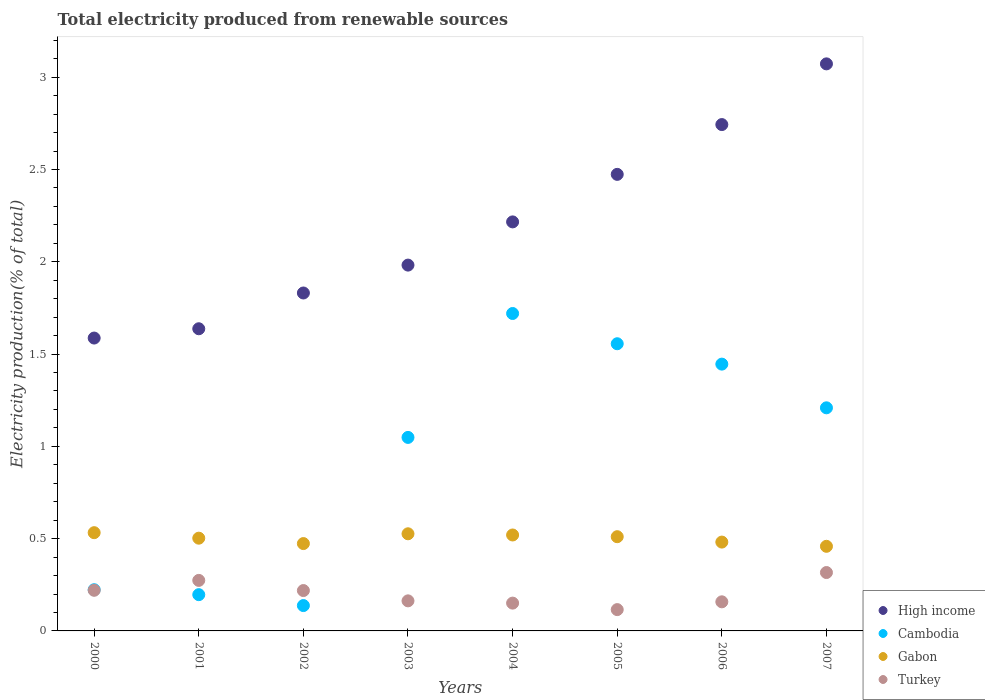What is the total electricity produced in Cambodia in 2005?
Provide a succinct answer. 1.56. Across all years, what is the maximum total electricity produced in Gabon?
Make the answer very short. 0.53. Across all years, what is the minimum total electricity produced in Turkey?
Make the answer very short. 0.12. In which year was the total electricity produced in Turkey maximum?
Provide a succinct answer. 2007. What is the total total electricity produced in Gabon in the graph?
Offer a terse response. 4. What is the difference between the total electricity produced in Turkey in 2005 and that in 2006?
Your answer should be compact. -0.04. What is the difference between the total electricity produced in Turkey in 2000 and the total electricity produced in Gabon in 2007?
Offer a terse response. -0.24. What is the average total electricity produced in Turkey per year?
Ensure brevity in your answer.  0.2. In the year 2002, what is the difference between the total electricity produced in Turkey and total electricity produced in High income?
Provide a succinct answer. -1.61. In how many years, is the total electricity produced in Turkey greater than 1.2 %?
Your answer should be very brief. 0. What is the ratio of the total electricity produced in Gabon in 2006 to that in 2007?
Your answer should be very brief. 1.05. Is the total electricity produced in Gabon in 2000 less than that in 2006?
Your response must be concise. No. Is the difference between the total electricity produced in Turkey in 2002 and 2003 greater than the difference between the total electricity produced in High income in 2002 and 2003?
Keep it short and to the point. Yes. What is the difference between the highest and the second highest total electricity produced in Gabon?
Give a very brief answer. 0.01. What is the difference between the highest and the lowest total electricity produced in Turkey?
Your answer should be compact. 0.2. Is the sum of the total electricity produced in Gabon in 2006 and 2007 greater than the maximum total electricity produced in High income across all years?
Ensure brevity in your answer.  No. Is it the case that in every year, the sum of the total electricity produced in Gabon and total electricity produced in Cambodia  is greater than the total electricity produced in High income?
Provide a succinct answer. No. Is the total electricity produced in High income strictly greater than the total electricity produced in Cambodia over the years?
Provide a succinct answer. Yes. Is the total electricity produced in Cambodia strictly less than the total electricity produced in High income over the years?
Provide a short and direct response. Yes. How many dotlines are there?
Offer a terse response. 4. How many years are there in the graph?
Your answer should be very brief. 8. What is the difference between two consecutive major ticks on the Y-axis?
Ensure brevity in your answer.  0.5. Does the graph contain any zero values?
Your answer should be very brief. No. Does the graph contain grids?
Your response must be concise. No. Where does the legend appear in the graph?
Your response must be concise. Bottom right. How many legend labels are there?
Your response must be concise. 4. How are the legend labels stacked?
Offer a terse response. Vertical. What is the title of the graph?
Ensure brevity in your answer.  Total electricity produced from renewable sources. What is the label or title of the Y-axis?
Offer a very short reply. Electricity production(% of total). What is the Electricity production(% of total) of High income in 2000?
Offer a very short reply. 1.59. What is the Electricity production(% of total) of Cambodia in 2000?
Keep it short and to the point. 0.22. What is the Electricity production(% of total) in Gabon in 2000?
Offer a very short reply. 0.53. What is the Electricity production(% of total) in Turkey in 2000?
Ensure brevity in your answer.  0.22. What is the Electricity production(% of total) of High income in 2001?
Your answer should be very brief. 1.64. What is the Electricity production(% of total) in Cambodia in 2001?
Your answer should be compact. 0.2. What is the Electricity production(% of total) of Gabon in 2001?
Give a very brief answer. 0.5. What is the Electricity production(% of total) of Turkey in 2001?
Your answer should be compact. 0.27. What is the Electricity production(% of total) in High income in 2002?
Ensure brevity in your answer.  1.83. What is the Electricity production(% of total) in Cambodia in 2002?
Offer a terse response. 0.14. What is the Electricity production(% of total) in Gabon in 2002?
Your response must be concise. 0.47. What is the Electricity production(% of total) of Turkey in 2002?
Give a very brief answer. 0.22. What is the Electricity production(% of total) of High income in 2003?
Keep it short and to the point. 1.98. What is the Electricity production(% of total) in Cambodia in 2003?
Give a very brief answer. 1.05. What is the Electricity production(% of total) in Gabon in 2003?
Your answer should be compact. 0.53. What is the Electricity production(% of total) of Turkey in 2003?
Offer a terse response. 0.16. What is the Electricity production(% of total) in High income in 2004?
Offer a very short reply. 2.22. What is the Electricity production(% of total) of Cambodia in 2004?
Offer a terse response. 1.72. What is the Electricity production(% of total) of Gabon in 2004?
Provide a short and direct response. 0.52. What is the Electricity production(% of total) of Turkey in 2004?
Make the answer very short. 0.15. What is the Electricity production(% of total) in High income in 2005?
Your answer should be very brief. 2.47. What is the Electricity production(% of total) of Cambodia in 2005?
Your answer should be very brief. 1.56. What is the Electricity production(% of total) of Gabon in 2005?
Your response must be concise. 0.51. What is the Electricity production(% of total) of Turkey in 2005?
Give a very brief answer. 0.12. What is the Electricity production(% of total) of High income in 2006?
Your response must be concise. 2.74. What is the Electricity production(% of total) of Cambodia in 2006?
Keep it short and to the point. 1.45. What is the Electricity production(% of total) in Gabon in 2006?
Make the answer very short. 0.48. What is the Electricity production(% of total) in Turkey in 2006?
Offer a very short reply. 0.16. What is the Electricity production(% of total) of High income in 2007?
Offer a terse response. 3.07. What is the Electricity production(% of total) in Cambodia in 2007?
Your response must be concise. 1.21. What is the Electricity production(% of total) of Gabon in 2007?
Ensure brevity in your answer.  0.46. What is the Electricity production(% of total) of Turkey in 2007?
Give a very brief answer. 0.32. Across all years, what is the maximum Electricity production(% of total) in High income?
Your answer should be very brief. 3.07. Across all years, what is the maximum Electricity production(% of total) of Cambodia?
Give a very brief answer. 1.72. Across all years, what is the maximum Electricity production(% of total) in Gabon?
Provide a short and direct response. 0.53. Across all years, what is the maximum Electricity production(% of total) in Turkey?
Provide a short and direct response. 0.32. Across all years, what is the minimum Electricity production(% of total) in High income?
Offer a terse response. 1.59. Across all years, what is the minimum Electricity production(% of total) in Cambodia?
Provide a short and direct response. 0.14. Across all years, what is the minimum Electricity production(% of total) in Gabon?
Offer a terse response. 0.46. Across all years, what is the minimum Electricity production(% of total) in Turkey?
Your answer should be compact. 0.12. What is the total Electricity production(% of total) in High income in the graph?
Give a very brief answer. 17.54. What is the total Electricity production(% of total) in Cambodia in the graph?
Keep it short and to the point. 7.54. What is the total Electricity production(% of total) in Gabon in the graph?
Provide a short and direct response. 4. What is the total Electricity production(% of total) in Turkey in the graph?
Offer a terse response. 1.62. What is the difference between the Electricity production(% of total) of High income in 2000 and that in 2001?
Keep it short and to the point. -0.05. What is the difference between the Electricity production(% of total) in Cambodia in 2000 and that in 2001?
Your answer should be compact. 0.03. What is the difference between the Electricity production(% of total) in Gabon in 2000 and that in 2001?
Your response must be concise. 0.03. What is the difference between the Electricity production(% of total) of Turkey in 2000 and that in 2001?
Keep it short and to the point. -0.05. What is the difference between the Electricity production(% of total) in High income in 2000 and that in 2002?
Provide a short and direct response. -0.24. What is the difference between the Electricity production(% of total) of Cambodia in 2000 and that in 2002?
Keep it short and to the point. 0.09. What is the difference between the Electricity production(% of total) of Gabon in 2000 and that in 2002?
Provide a succinct answer. 0.06. What is the difference between the Electricity production(% of total) of Turkey in 2000 and that in 2002?
Your answer should be very brief. 0. What is the difference between the Electricity production(% of total) in High income in 2000 and that in 2003?
Give a very brief answer. -0.4. What is the difference between the Electricity production(% of total) in Cambodia in 2000 and that in 2003?
Offer a terse response. -0.83. What is the difference between the Electricity production(% of total) of Gabon in 2000 and that in 2003?
Your answer should be very brief. 0.01. What is the difference between the Electricity production(% of total) in Turkey in 2000 and that in 2003?
Ensure brevity in your answer.  0.06. What is the difference between the Electricity production(% of total) in High income in 2000 and that in 2004?
Ensure brevity in your answer.  -0.63. What is the difference between the Electricity production(% of total) of Cambodia in 2000 and that in 2004?
Keep it short and to the point. -1.5. What is the difference between the Electricity production(% of total) in Gabon in 2000 and that in 2004?
Make the answer very short. 0.01. What is the difference between the Electricity production(% of total) of Turkey in 2000 and that in 2004?
Offer a terse response. 0.07. What is the difference between the Electricity production(% of total) of High income in 2000 and that in 2005?
Offer a terse response. -0.89. What is the difference between the Electricity production(% of total) of Cambodia in 2000 and that in 2005?
Your answer should be compact. -1.33. What is the difference between the Electricity production(% of total) in Gabon in 2000 and that in 2005?
Keep it short and to the point. 0.02. What is the difference between the Electricity production(% of total) of Turkey in 2000 and that in 2005?
Your answer should be compact. 0.1. What is the difference between the Electricity production(% of total) of High income in 2000 and that in 2006?
Make the answer very short. -1.16. What is the difference between the Electricity production(% of total) of Cambodia in 2000 and that in 2006?
Provide a short and direct response. -1.22. What is the difference between the Electricity production(% of total) in Gabon in 2000 and that in 2006?
Your answer should be compact. 0.05. What is the difference between the Electricity production(% of total) in Turkey in 2000 and that in 2006?
Ensure brevity in your answer.  0.06. What is the difference between the Electricity production(% of total) of High income in 2000 and that in 2007?
Your response must be concise. -1.49. What is the difference between the Electricity production(% of total) of Cambodia in 2000 and that in 2007?
Your answer should be very brief. -0.99. What is the difference between the Electricity production(% of total) in Gabon in 2000 and that in 2007?
Your answer should be compact. 0.07. What is the difference between the Electricity production(% of total) in Turkey in 2000 and that in 2007?
Offer a very short reply. -0.1. What is the difference between the Electricity production(% of total) of High income in 2001 and that in 2002?
Your answer should be very brief. -0.19. What is the difference between the Electricity production(% of total) of Cambodia in 2001 and that in 2002?
Offer a very short reply. 0.06. What is the difference between the Electricity production(% of total) in Gabon in 2001 and that in 2002?
Your answer should be compact. 0.03. What is the difference between the Electricity production(% of total) in Turkey in 2001 and that in 2002?
Your answer should be compact. 0.06. What is the difference between the Electricity production(% of total) of High income in 2001 and that in 2003?
Your response must be concise. -0.34. What is the difference between the Electricity production(% of total) in Cambodia in 2001 and that in 2003?
Give a very brief answer. -0.85. What is the difference between the Electricity production(% of total) in Gabon in 2001 and that in 2003?
Offer a terse response. -0.02. What is the difference between the Electricity production(% of total) in Turkey in 2001 and that in 2003?
Your answer should be compact. 0.11. What is the difference between the Electricity production(% of total) in High income in 2001 and that in 2004?
Provide a short and direct response. -0.58. What is the difference between the Electricity production(% of total) in Cambodia in 2001 and that in 2004?
Offer a terse response. -1.52. What is the difference between the Electricity production(% of total) in Gabon in 2001 and that in 2004?
Make the answer very short. -0.02. What is the difference between the Electricity production(% of total) of Turkey in 2001 and that in 2004?
Provide a short and direct response. 0.12. What is the difference between the Electricity production(% of total) of High income in 2001 and that in 2005?
Ensure brevity in your answer.  -0.84. What is the difference between the Electricity production(% of total) in Cambodia in 2001 and that in 2005?
Offer a very short reply. -1.36. What is the difference between the Electricity production(% of total) of Gabon in 2001 and that in 2005?
Ensure brevity in your answer.  -0.01. What is the difference between the Electricity production(% of total) in Turkey in 2001 and that in 2005?
Ensure brevity in your answer.  0.16. What is the difference between the Electricity production(% of total) in High income in 2001 and that in 2006?
Offer a terse response. -1.11. What is the difference between the Electricity production(% of total) of Cambodia in 2001 and that in 2006?
Offer a very short reply. -1.25. What is the difference between the Electricity production(% of total) in Gabon in 2001 and that in 2006?
Offer a terse response. 0.02. What is the difference between the Electricity production(% of total) in Turkey in 2001 and that in 2006?
Make the answer very short. 0.12. What is the difference between the Electricity production(% of total) of High income in 2001 and that in 2007?
Make the answer very short. -1.44. What is the difference between the Electricity production(% of total) of Cambodia in 2001 and that in 2007?
Keep it short and to the point. -1.01. What is the difference between the Electricity production(% of total) in Gabon in 2001 and that in 2007?
Your response must be concise. 0.04. What is the difference between the Electricity production(% of total) in Turkey in 2001 and that in 2007?
Keep it short and to the point. -0.04. What is the difference between the Electricity production(% of total) in High income in 2002 and that in 2003?
Your response must be concise. -0.15. What is the difference between the Electricity production(% of total) of Cambodia in 2002 and that in 2003?
Your answer should be compact. -0.91. What is the difference between the Electricity production(% of total) of Gabon in 2002 and that in 2003?
Your response must be concise. -0.05. What is the difference between the Electricity production(% of total) in Turkey in 2002 and that in 2003?
Give a very brief answer. 0.06. What is the difference between the Electricity production(% of total) in High income in 2002 and that in 2004?
Your answer should be very brief. -0.39. What is the difference between the Electricity production(% of total) in Cambodia in 2002 and that in 2004?
Offer a terse response. -1.58. What is the difference between the Electricity production(% of total) in Gabon in 2002 and that in 2004?
Give a very brief answer. -0.05. What is the difference between the Electricity production(% of total) in Turkey in 2002 and that in 2004?
Offer a very short reply. 0.07. What is the difference between the Electricity production(% of total) of High income in 2002 and that in 2005?
Give a very brief answer. -0.64. What is the difference between the Electricity production(% of total) in Cambodia in 2002 and that in 2005?
Provide a short and direct response. -1.42. What is the difference between the Electricity production(% of total) of Gabon in 2002 and that in 2005?
Make the answer very short. -0.04. What is the difference between the Electricity production(% of total) of Turkey in 2002 and that in 2005?
Offer a very short reply. 0.1. What is the difference between the Electricity production(% of total) in High income in 2002 and that in 2006?
Your answer should be very brief. -0.91. What is the difference between the Electricity production(% of total) in Cambodia in 2002 and that in 2006?
Provide a short and direct response. -1.31. What is the difference between the Electricity production(% of total) of Gabon in 2002 and that in 2006?
Keep it short and to the point. -0.01. What is the difference between the Electricity production(% of total) in Turkey in 2002 and that in 2006?
Your answer should be very brief. 0.06. What is the difference between the Electricity production(% of total) of High income in 2002 and that in 2007?
Give a very brief answer. -1.24. What is the difference between the Electricity production(% of total) of Cambodia in 2002 and that in 2007?
Offer a terse response. -1.07. What is the difference between the Electricity production(% of total) in Gabon in 2002 and that in 2007?
Provide a short and direct response. 0.01. What is the difference between the Electricity production(% of total) in Turkey in 2002 and that in 2007?
Your answer should be compact. -0.1. What is the difference between the Electricity production(% of total) in High income in 2003 and that in 2004?
Offer a very short reply. -0.23. What is the difference between the Electricity production(% of total) in Cambodia in 2003 and that in 2004?
Ensure brevity in your answer.  -0.67. What is the difference between the Electricity production(% of total) of Gabon in 2003 and that in 2004?
Offer a very short reply. 0.01. What is the difference between the Electricity production(% of total) in Turkey in 2003 and that in 2004?
Provide a succinct answer. 0.01. What is the difference between the Electricity production(% of total) in High income in 2003 and that in 2005?
Ensure brevity in your answer.  -0.49. What is the difference between the Electricity production(% of total) in Cambodia in 2003 and that in 2005?
Your answer should be compact. -0.51. What is the difference between the Electricity production(% of total) in Gabon in 2003 and that in 2005?
Keep it short and to the point. 0.02. What is the difference between the Electricity production(% of total) in Turkey in 2003 and that in 2005?
Make the answer very short. 0.05. What is the difference between the Electricity production(% of total) of High income in 2003 and that in 2006?
Keep it short and to the point. -0.76. What is the difference between the Electricity production(% of total) of Cambodia in 2003 and that in 2006?
Keep it short and to the point. -0.4. What is the difference between the Electricity production(% of total) in Gabon in 2003 and that in 2006?
Offer a very short reply. 0.04. What is the difference between the Electricity production(% of total) of Turkey in 2003 and that in 2006?
Offer a terse response. 0.01. What is the difference between the Electricity production(% of total) of High income in 2003 and that in 2007?
Ensure brevity in your answer.  -1.09. What is the difference between the Electricity production(% of total) of Cambodia in 2003 and that in 2007?
Your answer should be compact. -0.16. What is the difference between the Electricity production(% of total) in Gabon in 2003 and that in 2007?
Your answer should be very brief. 0.07. What is the difference between the Electricity production(% of total) in Turkey in 2003 and that in 2007?
Ensure brevity in your answer.  -0.15. What is the difference between the Electricity production(% of total) in High income in 2004 and that in 2005?
Your answer should be compact. -0.26. What is the difference between the Electricity production(% of total) of Cambodia in 2004 and that in 2005?
Offer a terse response. 0.16. What is the difference between the Electricity production(% of total) of Gabon in 2004 and that in 2005?
Offer a very short reply. 0.01. What is the difference between the Electricity production(% of total) in Turkey in 2004 and that in 2005?
Keep it short and to the point. 0.04. What is the difference between the Electricity production(% of total) in High income in 2004 and that in 2006?
Give a very brief answer. -0.53. What is the difference between the Electricity production(% of total) of Cambodia in 2004 and that in 2006?
Ensure brevity in your answer.  0.27. What is the difference between the Electricity production(% of total) of Gabon in 2004 and that in 2006?
Offer a terse response. 0.04. What is the difference between the Electricity production(% of total) of Turkey in 2004 and that in 2006?
Your response must be concise. -0.01. What is the difference between the Electricity production(% of total) of High income in 2004 and that in 2007?
Make the answer very short. -0.86. What is the difference between the Electricity production(% of total) in Cambodia in 2004 and that in 2007?
Your response must be concise. 0.51. What is the difference between the Electricity production(% of total) of Gabon in 2004 and that in 2007?
Offer a very short reply. 0.06. What is the difference between the Electricity production(% of total) of Turkey in 2004 and that in 2007?
Provide a short and direct response. -0.17. What is the difference between the Electricity production(% of total) of High income in 2005 and that in 2006?
Offer a very short reply. -0.27. What is the difference between the Electricity production(% of total) of Cambodia in 2005 and that in 2006?
Give a very brief answer. 0.11. What is the difference between the Electricity production(% of total) of Gabon in 2005 and that in 2006?
Your response must be concise. 0.03. What is the difference between the Electricity production(% of total) in Turkey in 2005 and that in 2006?
Offer a terse response. -0.04. What is the difference between the Electricity production(% of total) of High income in 2005 and that in 2007?
Your response must be concise. -0.6. What is the difference between the Electricity production(% of total) of Cambodia in 2005 and that in 2007?
Provide a short and direct response. 0.35. What is the difference between the Electricity production(% of total) in Gabon in 2005 and that in 2007?
Offer a terse response. 0.05. What is the difference between the Electricity production(% of total) in Turkey in 2005 and that in 2007?
Your answer should be compact. -0.2. What is the difference between the Electricity production(% of total) of High income in 2006 and that in 2007?
Provide a succinct answer. -0.33. What is the difference between the Electricity production(% of total) of Cambodia in 2006 and that in 2007?
Keep it short and to the point. 0.24. What is the difference between the Electricity production(% of total) in Gabon in 2006 and that in 2007?
Your answer should be compact. 0.02. What is the difference between the Electricity production(% of total) in Turkey in 2006 and that in 2007?
Offer a very short reply. -0.16. What is the difference between the Electricity production(% of total) of High income in 2000 and the Electricity production(% of total) of Cambodia in 2001?
Your answer should be compact. 1.39. What is the difference between the Electricity production(% of total) of High income in 2000 and the Electricity production(% of total) of Gabon in 2001?
Your answer should be very brief. 1.08. What is the difference between the Electricity production(% of total) of High income in 2000 and the Electricity production(% of total) of Turkey in 2001?
Give a very brief answer. 1.31. What is the difference between the Electricity production(% of total) in Cambodia in 2000 and the Electricity production(% of total) in Gabon in 2001?
Provide a short and direct response. -0.28. What is the difference between the Electricity production(% of total) of Cambodia in 2000 and the Electricity production(% of total) of Turkey in 2001?
Offer a terse response. -0.05. What is the difference between the Electricity production(% of total) of Gabon in 2000 and the Electricity production(% of total) of Turkey in 2001?
Provide a short and direct response. 0.26. What is the difference between the Electricity production(% of total) in High income in 2000 and the Electricity production(% of total) in Cambodia in 2002?
Your answer should be very brief. 1.45. What is the difference between the Electricity production(% of total) of High income in 2000 and the Electricity production(% of total) of Gabon in 2002?
Give a very brief answer. 1.11. What is the difference between the Electricity production(% of total) in High income in 2000 and the Electricity production(% of total) in Turkey in 2002?
Ensure brevity in your answer.  1.37. What is the difference between the Electricity production(% of total) in Cambodia in 2000 and the Electricity production(% of total) in Gabon in 2002?
Ensure brevity in your answer.  -0.25. What is the difference between the Electricity production(% of total) in Cambodia in 2000 and the Electricity production(% of total) in Turkey in 2002?
Provide a short and direct response. 0. What is the difference between the Electricity production(% of total) in Gabon in 2000 and the Electricity production(% of total) in Turkey in 2002?
Offer a very short reply. 0.31. What is the difference between the Electricity production(% of total) in High income in 2000 and the Electricity production(% of total) in Cambodia in 2003?
Make the answer very short. 0.54. What is the difference between the Electricity production(% of total) in High income in 2000 and the Electricity production(% of total) in Gabon in 2003?
Keep it short and to the point. 1.06. What is the difference between the Electricity production(% of total) in High income in 2000 and the Electricity production(% of total) in Turkey in 2003?
Ensure brevity in your answer.  1.42. What is the difference between the Electricity production(% of total) of Cambodia in 2000 and the Electricity production(% of total) of Gabon in 2003?
Your answer should be compact. -0.3. What is the difference between the Electricity production(% of total) of Cambodia in 2000 and the Electricity production(% of total) of Turkey in 2003?
Provide a succinct answer. 0.06. What is the difference between the Electricity production(% of total) of Gabon in 2000 and the Electricity production(% of total) of Turkey in 2003?
Keep it short and to the point. 0.37. What is the difference between the Electricity production(% of total) of High income in 2000 and the Electricity production(% of total) of Cambodia in 2004?
Keep it short and to the point. -0.13. What is the difference between the Electricity production(% of total) in High income in 2000 and the Electricity production(% of total) in Gabon in 2004?
Provide a succinct answer. 1.07. What is the difference between the Electricity production(% of total) of High income in 2000 and the Electricity production(% of total) of Turkey in 2004?
Provide a succinct answer. 1.44. What is the difference between the Electricity production(% of total) in Cambodia in 2000 and the Electricity production(% of total) in Gabon in 2004?
Ensure brevity in your answer.  -0.3. What is the difference between the Electricity production(% of total) in Cambodia in 2000 and the Electricity production(% of total) in Turkey in 2004?
Provide a short and direct response. 0.07. What is the difference between the Electricity production(% of total) in Gabon in 2000 and the Electricity production(% of total) in Turkey in 2004?
Your answer should be very brief. 0.38. What is the difference between the Electricity production(% of total) in High income in 2000 and the Electricity production(% of total) in Cambodia in 2005?
Your response must be concise. 0.03. What is the difference between the Electricity production(% of total) of High income in 2000 and the Electricity production(% of total) of Gabon in 2005?
Your answer should be very brief. 1.08. What is the difference between the Electricity production(% of total) of High income in 2000 and the Electricity production(% of total) of Turkey in 2005?
Make the answer very short. 1.47. What is the difference between the Electricity production(% of total) of Cambodia in 2000 and the Electricity production(% of total) of Gabon in 2005?
Your answer should be compact. -0.29. What is the difference between the Electricity production(% of total) of Cambodia in 2000 and the Electricity production(% of total) of Turkey in 2005?
Your response must be concise. 0.11. What is the difference between the Electricity production(% of total) of Gabon in 2000 and the Electricity production(% of total) of Turkey in 2005?
Your answer should be compact. 0.42. What is the difference between the Electricity production(% of total) in High income in 2000 and the Electricity production(% of total) in Cambodia in 2006?
Offer a terse response. 0.14. What is the difference between the Electricity production(% of total) of High income in 2000 and the Electricity production(% of total) of Gabon in 2006?
Your response must be concise. 1.11. What is the difference between the Electricity production(% of total) of High income in 2000 and the Electricity production(% of total) of Turkey in 2006?
Give a very brief answer. 1.43. What is the difference between the Electricity production(% of total) of Cambodia in 2000 and the Electricity production(% of total) of Gabon in 2006?
Your answer should be very brief. -0.26. What is the difference between the Electricity production(% of total) in Cambodia in 2000 and the Electricity production(% of total) in Turkey in 2006?
Make the answer very short. 0.07. What is the difference between the Electricity production(% of total) in Gabon in 2000 and the Electricity production(% of total) in Turkey in 2006?
Your answer should be very brief. 0.37. What is the difference between the Electricity production(% of total) in High income in 2000 and the Electricity production(% of total) in Cambodia in 2007?
Your answer should be very brief. 0.38. What is the difference between the Electricity production(% of total) of High income in 2000 and the Electricity production(% of total) of Gabon in 2007?
Your response must be concise. 1.13. What is the difference between the Electricity production(% of total) of High income in 2000 and the Electricity production(% of total) of Turkey in 2007?
Your response must be concise. 1.27. What is the difference between the Electricity production(% of total) of Cambodia in 2000 and the Electricity production(% of total) of Gabon in 2007?
Your answer should be very brief. -0.24. What is the difference between the Electricity production(% of total) in Cambodia in 2000 and the Electricity production(% of total) in Turkey in 2007?
Offer a terse response. -0.09. What is the difference between the Electricity production(% of total) of Gabon in 2000 and the Electricity production(% of total) of Turkey in 2007?
Make the answer very short. 0.22. What is the difference between the Electricity production(% of total) in High income in 2001 and the Electricity production(% of total) in Cambodia in 2002?
Your response must be concise. 1.5. What is the difference between the Electricity production(% of total) in High income in 2001 and the Electricity production(% of total) in Gabon in 2002?
Provide a short and direct response. 1.16. What is the difference between the Electricity production(% of total) of High income in 2001 and the Electricity production(% of total) of Turkey in 2002?
Provide a short and direct response. 1.42. What is the difference between the Electricity production(% of total) of Cambodia in 2001 and the Electricity production(% of total) of Gabon in 2002?
Provide a succinct answer. -0.28. What is the difference between the Electricity production(% of total) of Cambodia in 2001 and the Electricity production(% of total) of Turkey in 2002?
Keep it short and to the point. -0.02. What is the difference between the Electricity production(% of total) of Gabon in 2001 and the Electricity production(% of total) of Turkey in 2002?
Your response must be concise. 0.28. What is the difference between the Electricity production(% of total) of High income in 2001 and the Electricity production(% of total) of Cambodia in 2003?
Provide a succinct answer. 0.59. What is the difference between the Electricity production(% of total) of High income in 2001 and the Electricity production(% of total) of Gabon in 2003?
Make the answer very short. 1.11. What is the difference between the Electricity production(% of total) in High income in 2001 and the Electricity production(% of total) in Turkey in 2003?
Your answer should be very brief. 1.47. What is the difference between the Electricity production(% of total) in Cambodia in 2001 and the Electricity production(% of total) in Gabon in 2003?
Offer a terse response. -0.33. What is the difference between the Electricity production(% of total) of Cambodia in 2001 and the Electricity production(% of total) of Turkey in 2003?
Provide a short and direct response. 0.03. What is the difference between the Electricity production(% of total) of Gabon in 2001 and the Electricity production(% of total) of Turkey in 2003?
Your answer should be very brief. 0.34. What is the difference between the Electricity production(% of total) of High income in 2001 and the Electricity production(% of total) of Cambodia in 2004?
Provide a short and direct response. -0.08. What is the difference between the Electricity production(% of total) of High income in 2001 and the Electricity production(% of total) of Gabon in 2004?
Offer a terse response. 1.12. What is the difference between the Electricity production(% of total) in High income in 2001 and the Electricity production(% of total) in Turkey in 2004?
Your response must be concise. 1.49. What is the difference between the Electricity production(% of total) in Cambodia in 2001 and the Electricity production(% of total) in Gabon in 2004?
Give a very brief answer. -0.32. What is the difference between the Electricity production(% of total) in Cambodia in 2001 and the Electricity production(% of total) in Turkey in 2004?
Your answer should be very brief. 0.05. What is the difference between the Electricity production(% of total) of Gabon in 2001 and the Electricity production(% of total) of Turkey in 2004?
Your response must be concise. 0.35. What is the difference between the Electricity production(% of total) in High income in 2001 and the Electricity production(% of total) in Cambodia in 2005?
Provide a short and direct response. 0.08. What is the difference between the Electricity production(% of total) of High income in 2001 and the Electricity production(% of total) of Gabon in 2005?
Provide a succinct answer. 1.13. What is the difference between the Electricity production(% of total) in High income in 2001 and the Electricity production(% of total) in Turkey in 2005?
Your response must be concise. 1.52. What is the difference between the Electricity production(% of total) in Cambodia in 2001 and the Electricity production(% of total) in Gabon in 2005?
Provide a succinct answer. -0.31. What is the difference between the Electricity production(% of total) of Cambodia in 2001 and the Electricity production(% of total) of Turkey in 2005?
Provide a succinct answer. 0.08. What is the difference between the Electricity production(% of total) of Gabon in 2001 and the Electricity production(% of total) of Turkey in 2005?
Keep it short and to the point. 0.39. What is the difference between the Electricity production(% of total) in High income in 2001 and the Electricity production(% of total) in Cambodia in 2006?
Your response must be concise. 0.19. What is the difference between the Electricity production(% of total) in High income in 2001 and the Electricity production(% of total) in Gabon in 2006?
Ensure brevity in your answer.  1.16. What is the difference between the Electricity production(% of total) of High income in 2001 and the Electricity production(% of total) of Turkey in 2006?
Your response must be concise. 1.48. What is the difference between the Electricity production(% of total) of Cambodia in 2001 and the Electricity production(% of total) of Gabon in 2006?
Your response must be concise. -0.28. What is the difference between the Electricity production(% of total) in Cambodia in 2001 and the Electricity production(% of total) in Turkey in 2006?
Your answer should be very brief. 0.04. What is the difference between the Electricity production(% of total) in Gabon in 2001 and the Electricity production(% of total) in Turkey in 2006?
Offer a terse response. 0.34. What is the difference between the Electricity production(% of total) in High income in 2001 and the Electricity production(% of total) in Cambodia in 2007?
Your answer should be very brief. 0.43. What is the difference between the Electricity production(% of total) in High income in 2001 and the Electricity production(% of total) in Gabon in 2007?
Provide a succinct answer. 1.18. What is the difference between the Electricity production(% of total) of High income in 2001 and the Electricity production(% of total) of Turkey in 2007?
Keep it short and to the point. 1.32. What is the difference between the Electricity production(% of total) of Cambodia in 2001 and the Electricity production(% of total) of Gabon in 2007?
Your answer should be compact. -0.26. What is the difference between the Electricity production(% of total) of Cambodia in 2001 and the Electricity production(% of total) of Turkey in 2007?
Your answer should be compact. -0.12. What is the difference between the Electricity production(% of total) of Gabon in 2001 and the Electricity production(% of total) of Turkey in 2007?
Give a very brief answer. 0.19. What is the difference between the Electricity production(% of total) in High income in 2002 and the Electricity production(% of total) in Cambodia in 2003?
Your response must be concise. 0.78. What is the difference between the Electricity production(% of total) of High income in 2002 and the Electricity production(% of total) of Gabon in 2003?
Make the answer very short. 1.3. What is the difference between the Electricity production(% of total) of High income in 2002 and the Electricity production(% of total) of Turkey in 2003?
Give a very brief answer. 1.67. What is the difference between the Electricity production(% of total) in Cambodia in 2002 and the Electricity production(% of total) in Gabon in 2003?
Keep it short and to the point. -0.39. What is the difference between the Electricity production(% of total) in Cambodia in 2002 and the Electricity production(% of total) in Turkey in 2003?
Your answer should be compact. -0.03. What is the difference between the Electricity production(% of total) of Gabon in 2002 and the Electricity production(% of total) of Turkey in 2003?
Give a very brief answer. 0.31. What is the difference between the Electricity production(% of total) in High income in 2002 and the Electricity production(% of total) in Cambodia in 2004?
Keep it short and to the point. 0.11. What is the difference between the Electricity production(% of total) in High income in 2002 and the Electricity production(% of total) in Gabon in 2004?
Give a very brief answer. 1.31. What is the difference between the Electricity production(% of total) in High income in 2002 and the Electricity production(% of total) in Turkey in 2004?
Offer a very short reply. 1.68. What is the difference between the Electricity production(% of total) in Cambodia in 2002 and the Electricity production(% of total) in Gabon in 2004?
Your answer should be compact. -0.38. What is the difference between the Electricity production(% of total) of Cambodia in 2002 and the Electricity production(% of total) of Turkey in 2004?
Ensure brevity in your answer.  -0.01. What is the difference between the Electricity production(% of total) in Gabon in 2002 and the Electricity production(% of total) in Turkey in 2004?
Offer a very short reply. 0.32. What is the difference between the Electricity production(% of total) in High income in 2002 and the Electricity production(% of total) in Cambodia in 2005?
Your answer should be compact. 0.28. What is the difference between the Electricity production(% of total) of High income in 2002 and the Electricity production(% of total) of Gabon in 2005?
Offer a terse response. 1.32. What is the difference between the Electricity production(% of total) of High income in 2002 and the Electricity production(% of total) of Turkey in 2005?
Ensure brevity in your answer.  1.72. What is the difference between the Electricity production(% of total) in Cambodia in 2002 and the Electricity production(% of total) in Gabon in 2005?
Give a very brief answer. -0.37. What is the difference between the Electricity production(% of total) of Cambodia in 2002 and the Electricity production(% of total) of Turkey in 2005?
Provide a short and direct response. 0.02. What is the difference between the Electricity production(% of total) in Gabon in 2002 and the Electricity production(% of total) in Turkey in 2005?
Your answer should be compact. 0.36. What is the difference between the Electricity production(% of total) of High income in 2002 and the Electricity production(% of total) of Cambodia in 2006?
Give a very brief answer. 0.39. What is the difference between the Electricity production(% of total) in High income in 2002 and the Electricity production(% of total) in Gabon in 2006?
Offer a terse response. 1.35. What is the difference between the Electricity production(% of total) of High income in 2002 and the Electricity production(% of total) of Turkey in 2006?
Your answer should be compact. 1.67. What is the difference between the Electricity production(% of total) in Cambodia in 2002 and the Electricity production(% of total) in Gabon in 2006?
Keep it short and to the point. -0.34. What is the difference between the Electricity production(% of total) in Cambodia in 2002 and the Electricity production(% of total) in Turkey in 2006?
Keep it short and to the point. -0.02. What is the difference between the Electricity production(% of total) in Gabon in 2002 and the Electricity production(% of total) in Turkey in 2006?
Make the answer very short. 0.32. What is the difference between the Electricity production(% of total) in High income in 2002 and the Electricity production(% of total) in Cambodia in 2007?
Your answer should be compact. 0.62. What is the difference between the Electricity production(% of total) of High income in 2002 and the Electricity production(% of total) of Gabon in 2007?
Offer a terse response. 1.37. What is the difference between the Electricity production(% of total) of High income in 2002 and the Electricity production(% of total) of Turkey in 2007?
Provide a succinct answer. 1.51. What is the difference between the Electricity production(% of total) in Cambodia in 2002 and the Electricity production(% of total) in Gabon in 2007?
Your answer should be compact. -0.32. What is the difference between the Electricity production(% of total) of Cambodia in 2002 and the Electricity production(% of total) of Turkey in 2007?
Ensure brevity in your answer.  -0.18. What is the difference between the Electricity production(% of total) in Gabon in 2002 and the Electricity production(% of total) in Turkey in 2007?
Ensure brevity in your answer.  0.16. What is the difference between the Electricity production(% of total) in High income in 2003 and the Electricity production(% of total) in Cambodia in 2004?
Make the answer very short. 0.26. What is the difference between the Electricity production(% of total) of High income in 2003 and the Electricity production(% of total) of Gabon in 2004?
Your response must be concise. 1.46. What is the difference between the Electricity production(% of total) in High income in 2003 and the Electricity production(% of total) in Turkey in 2004?
Your answer should be compact. 1.83. What is the difference between the Electricity production(% of total) in Cambodia in 2003 and the Electricity production(% of total) in Gabon in 2004?
Offer a very short reply. 0.53. What is the difference between the Electricity production(% of total) in Cambodia in 2003 and the Electricity production(% of total) in Turkey in 2004?
Provide a succinct answer. 0.9. What is the difference between the Electricity production(% of total) in Gabon in 2003 and the Electricity production(% of total) in Turkey in 2004?
Your answer should be compact. 0.38. What is the difference between the Electricity production(% of total) of High income in 2003 and the Electricity production(% of total) of Cambodia in 2005?
Provide a short and direct response. 0.43. What is the difference between the Electricity production(% of total) in High income in 2003 and the Electricity production(% of total) in Gabon in 2005?
Provide a short and direct response. 1.47. What is the difference between the Electricity production(% of total) in High income in 2003 and the Electricity production(% of total) in Turkey in 2005?
Your answer should be very brief. 1.87. What is the difference between the Electricity production(% of total) of Cambodia in 2003 and the Electricity production(% of total) of Gabon in 2005?
Your response must be concise. 0.54. What is the difference between the Electricity production(% of total) in Cambodia in 2003 and the Electricity production(% of total) in Turkey in 2005?
Provide a succinct answer. 0.93. What is the difference between the Electricity production(% of total) in Gabon in 2003 and the Electricity production(% of total) in Turkey in 2005?
Make the answer very short. 0.41. What is the difference between the Electricity production(% of total) in High income in 2003 and the Electricity production(% of total) in Cambodia in 2006?
Offer a terse response. 0.54. What is the difference between the Electricity production(% of total) in High income in 2003 and the Electricity production(% of total) in Gabon in 2006?
Ensure brevity in your answer.  1.5. What is the difference between the Electricity production(% of total) of High income in 2003 and the Electricity production(% of total) of Turkey in 2006?
Offer a very short reply. 1.82. What is the difference between the Electricity production(% of total) of Cambodia in 2003 and the Electricity production(% of total) of Gabon in 2006?
Provide a short and direct response. 0.57. What is the difference between the Electricity production(% of total) of Cambodia in 2003 and the Electricity production(% of total) of Turkey in 2006?
Provide a succinct answer. 0.89. What is the difference between the Electricity production(% of total) in Gabon in 2003 and the Electricity production(% of total) in Turkey in 2006?
Provide a short and direct response. 0.37. What is the difference between the Electricity production(% of total) of High income in 2003 and the Electricity production(% of total) of Cambodia in 2007?
Your response must be concise. 0.77. What is the difference between the Electricity production(% of total) of High income in 2003 and the Electricity production(% of total) of Gabon in 2007?
Provide a succinct answer. 1.52. What is the difference between the Electricity production(% of total) in High income in 2003 and the Electricity production(% of total) in Turkey in 2007?
Your answer should be compact. 1.67. What is the difference between the Electricity production(% of total) in Cambodia in 2003 and the Electricity production(% of total) in Gabon in 2007?
Your answer should be very brief. 0.59. What is the difference between the Electricity production(% of total) in Cambodia in 2003 and the Electricity production(% of total) in Turkey in 2007?
Keep it short and to the point. 0.73. What is the difference between the Electricity production(% of total) in Gabon in 2003 and the Electricity production(% of total) in Turkey in 2007?
Offer a very short reply. 0.21. What is the difference between the Electricity production(% of total) of High income in 2004 and the Electricity production(% of total) of Cambodia in 2005?
Give a very brief answer. 0.66. What is the difference between the Electricity production(% of total) in High income in 2004 and the Electricity production(% of total) in Gabon in 2005?
Provide a short and direct response. 1.71. What is the difference between the Electricity production(% of total) in High income in 2004 and the Electricity production(% of total) in Turkey in 2005?
Offer a terse response. 2.1. What is the difference between the Electricity production(% of total) of Cambodia in 2004 and the Electricity production(% of total) of Gabon in 2005?
Keep it short and to the point. 1.21. What is the difference between the Electricity production(% of total) in Cambodia in 2004 and the Electricity production(% of total) in Turkey in 2005?
Provide a succinct answer. 1.6. What is the difference between the Electricity production(% of total) of Gabon in 2004 and the Electricity production(% of total) of Turkey in 2005?
Offer a very short reply. 0.4. What is the difference between the Electricity production(% of total) in High income in 2004 and the Electricity production(% of total) in Cambodia in 2006?
Your response must be concise. 0.77. What is the difference between the Electricity production(% of total) in High income in 2004 and the Electricity production(% of total) in Gabon in 2006?
Keep it short and to the point. 1.73. What is the difference between the Electricity production(% of total) of High income in 2004 and the Electricity production(% of total) of Turkey in 2006?
Offer a terse response. 2.06. What is the difference between the Electricity production(% of total) of Cambodia in 2004 and the Electricity production(% of total) of Gabon in 2006?
Your answer should be very brief. 1.24. What is the difference between the Electricity production(% of total) of Cambodia in 2004 and the Electricity production(% of total) of Turkey in 2006?
Your answer should be compact. 1.56. What is the difference between the Electricity production(% of total) in Gabon in 2004 and the Electricity production(% of total) in Turkey in 2006?
Offer a very short reply. 0.36. What is the difference between the Electricity production(% of total) in High income in 2004 and the Electricity production(% of total) in Cambodia in 2007?
Your answer should be very brief. 1.01. What is the difference between the Electricity production(% of total) of High income in 2004 and the Electricity production(% of total) of Gabon in 2007?
Offer a very short reply. 1.76. What is the difference between the Electricity production(% of total) of High income in 2004 and the Electricity production(% of total) of Turkey in 2007?
Give a very brief answer. 1.9. What is the difference between the Electricity production(% of total) of Cambodia in 2004 and the Electricity production(% of total) of Gabon in 2007?
Your answer should be very brief. 1.26. What is the difference between the Electricity production(% of total) in Cambodia in 2004 and the Electricity production(% of total) in Turkey in 2007?
Your answer should be compact. 1.4. What is the difference between the Electricity production(% of total) in Gabon in 2004 and the Electricity production(% of total) in Turkey in 2007?
Offer a very short reply. 0.2. What is the difference between the Electricity production(% of total) in High income in 2005 and the Electricity production(% of total) in Cambodia in 2006?
Your response must be concise. 1.03. What is the difference between the Electricity production(% of total) of High income in 2005 and the Electricity production(% of total) of Gabon in 2006?
Provide a short and direct response. 1.99. What is the difference between the Electricity production(% of total) of High income in 2005 and the Electricity production(% of total) of Turkey in 2006?
Keep it short and to the point. 2.32. What is the difference between the Electricity production(% of total) of Cambodia in 2005 and the Electricity production(% of total) of Gabon in 2006?
Your response must be concise. 1.07. What is the difference between the Electricity production(% of total) in Cambodia in 2005 and the Electricity production(% of total) in Turkey in 2006?
Give a very brief answer. 1.4. What is the difference between the Electricity production(% of total) of Gabon in 2005 and the Electricity production(% of total) of Turkey in 2006?
Your response must be concise. 0.35. What is the difference between the Electricity production(% of total) in High income in 2005 and the Electricity production(% of total) in Cambodia in 2007?
Provide a succinct answer. 1.26. What is the difference between the Electricity production(% of total) in High income in 2005 and the Electricity production(% of total) in Gabon in 2007?
Give a very brief answer. 2.02. What is the difference between the Electricity production(% of total) of High income in 2005 and the Electricity production(% of total) of Turkey in 2007?
Your response must be concise. 2.16. What is the difference between the Electricity production(% of total) in Cambodia in 2005 and the Electricity production(% of total) in Gabon in 2007?
Your answer should be very brief. 1.1. What is the difference between the Electricity production(% of total) of Cambodia in 2005 and the Electricity production(% of total) of Turkey in 2007?
Provide a succinct answer. 1.24. What is the difference between the Electricity production(% of total) in Gabon in 2005 and the Electricity production(% of total) in Turkey in 2007?
Provide a succinct answer. 0.19. What is the difference between the Electricity production(% of total) in High income in 2006 and the Electricity production(% of total) in Cambodia in 2007?
Provide a short and direct response. 1.53. What is the difference between the Electricity production(% of total) in High income in 2006 and the Electricity production(% of total) in Gabon in 2007?
Your answer should be very brief. 2.29. What is the difference between the Electricity production(% of total) in High income in 2006 and the Electricity production(% of total) in Turkey in 2007?
Your answer should be compact. 2.43. What is the difference between the Electricity production(% of total) in Cambodia in 2006 and the Electricity production(% of total) in Gabon in 2007?
Give a very brief answer. 0.99. What is the difference between the Electricity production(% of total) of Cambodia in 2006 and the Electricity production(% of total) of Turkey in 2007?
Offer a very short reply. 1.13. What is the difference between the Electricity production(% of total) in Gabon in 2006 and the Electricity production(% of total) in Turkey in 2007?
Keep it short and to the point. 0.17. What is the average Electricity production(% of total) in High income per year?
Provide a succinct answer. 2.19. What is the average Electricity production(% of total) in Cambodia per year?
Offer a terse response. 0.94. What is the average Electricity production(% of total) of Gabon per year?
Make the answer very short. 0.5. What is the average Electricity production(% of total) of Turkey per year?
Offer a terse response. 0.2. In the year 2000, what is the difference between the Electricity production(% of total) in High income and Electricity production(% of total) in Cambodia?
Provide a short and direct response. 1.36. In the year 2000, what is the difference between the Electricity production(% of total) of High income and Electricity production(% of total) of Gabon?
Make the answer very short. 1.05. In the year 2000, what is the difference between the Electricity production(% of total) in High income and Electricity production(% of total) in Turkey?
Give a very brief answer. 1.37. In the year 2000, what is the difference between the Electricity production(% of total) in Cambodia and Electricity production(% of total) in Gabon?
Offer a very short reply. -0.31. In the year 2000, what is the difference between the Electricity production(% of total) of Cambodia and Electricity production(% of total) of Turkey?
Offer a very short reply. 0. In the year 2000, what is the difference between the Electricity production(% of total) of Gabon and Electricity production(% of total) of Turkey?
Your answer should be compact. 0.31. In the year 2001, what is the difference between the Electricity production(% of total) in High income and Electricity production(% of total) in Cambodia?
Give a very brief answer. 1.44. In the year 2001, what is the difference between the Electricity production(% of total) of High income and Electricity production(% of total) of Gabon?
Offer a terse response. 1.13. In the year 2001, what is the difference between the Electricity production(% of total) in High income and Electricity production(% of total) in Turkey?
Make the answer very short. 1.36. In the year 2001, what is the difference between the Electricity production(% of total) in Cambodia and Electricity production(% of total) in Gabon?
Your response must be concise. -0.31. In the year 2001, what is the difference between the Electricity production(% of total) in Cambodia and Electricity production(% of total) in Turkey?
Ensure brevity in your answer.  -0.08. In the year 2001, what is the difference between the Electricity production(% of total) in Gabon and Electricity production(% of total) in Turkey?
Your response must be concise. 0.23. In the year 2002, what is the difference between the Electricity production(% of total) of High income and Electricity production(% of total) of Cambodia?
Ensure brevity in your answer.  1.69. In the year 2002, what is the difference between the Electricity production(% of total) of High income and Electricity production(% of total) of Gabon?
Your answer should be compact. 1.36. In the year 2002, what is the difference between the Electricity production(% of total) of High income and Electricity production(% of total) of Turkey?
Your response must be concise. 1.61. In the year 2002, what is the difference between the Electricity production(% of total) of Cambodia and Electricity production(% of total) of Gabon?
Provide a succinct answer. -0.34. In the year 2002, what is the difference between the Electricity production(% of total) of Cambodia and Electricity production(% of total) of Turkey?
Ensure brevity in your answer.  -0.08. In the year 2002, what is the difference between the Electricity production(% of total) in Gabon and Electricity production(% of total) in Turkey?
Your answer should be compact. 0.25. In the year 2003, what is the difference between the Electricity production(% of total) in High income and Electricity production(% of total) in Cambodia?
Provide a succinct answer. 0.93. In the year 2003, what is the difference between the Electricity production(% of total) in High income and Electricity production(% of total) in Gabon?
Your answer should be compact. 1.46. In the year 2003, what is the difference between the Electricity production(% of total) in High income and Electricity production(% of total) in Turkey?
Provide a short and direct response. 1.82. In the year 2003, what is the difference between the Electricity production(% of total) of Cambodia and Electricity production(% of total) of Gabon?
Your answer should be compact. 0.52. In the year 2003, what is the difference between the Electricity production(% of total) of Cambodia and Electricity production(% of total) of Turkey?
Your response must be concise. 0.89. In the year 2003, what is the difference between the Electricity production(% of total) of Gabon and Electricity production(% of total) of Turkey?
Provide a short and direct response. 0.36. In the year 2004, what is the difference between the Electricity production(% of total) in High income and Electricity production(% of total) in Cambodia?
Provide a succinct answer. 0.5. In the year 2004, what is the difference between the Electricity production(% of total) in High income and Electricity production(% of total) in Gabon?
Your answer should be very brief. 1.7. In the year 2004, what is the difference between the Electricity production(% of total) of High income and Electricity production(% of total) of Turkey?
Offer a terse response. 2.07. In the year 2004, what is the difference between the Electricity production(% of total) in Cambodia and Electricity production(% of total) in Gabon?
Your answer should be compact. 1.2. In the year 2004, what is the difference between the Electricity production(% of total) of Cambodia and Electricity production(% of total) of Turkey?
Your answer should be very brief. 1.57. In the year 2004, what is the difference between the Electricity production(% of total) in Gabon and Electricity production(% of total) in Turkey?
Make the answer very short. 0.37. In the year 2005, what is the difference between the Electricity production(% of total) in High income and Electricity production(% of total) in Cambodia?
Provide a short and direct response. 0.92. In the year 2005, what is the difference between the Electricity production(% of total) of High income and Electricity production(% of total) of Gabon?
Offer a terse response. 1.96. In the year 2005, what is the difference between the Electricity production(% of total) in High income and Electricity production(% of total) in Turkey?
Provide a short and direct response. 2.36. In the year 2005, what is the difference between the Electricity production(% of total) of Cambodia and Electricity production(% of total) of Gabon?
Offer a terse response. 1.05. In the year 2005, what is the difference between the Electricity production(% of total) of Cambodia and Electricity production(% of total) of Turkey?
Make the answer very short. 1.44. In the year 2005, what is the difference between the Electricity production(% of total) of Gabon and Electricity production(% of total) of Turkey?
Provide a succinct answer. 0.4. In the year 2006, what is the difference between the Electricity production(% of total) of High income and Electricity production(% of total) of Cambodia?
Keep it short and to the point. 1.3. In the year 2006, what is the difference between the Electricity production(% of total) in High income and Electricity production(% of total) in Gabon?
Make the answer very short. 2.26. In the year 2006, what is the difference between the Electricity production(% of total) in High income and Electricity production(% of total) in Turkey?
Provide a succinct answer. 2.59. In the year 2006, what is the difference between the Electricity production(% of total) of Cambodia and Electricity production(% of total) of Gabon?
Your response must be concise. 0.96. In the year 2006, what is the difference between the Electricity production(% of total) in Cambodia and Electricity production(% of total) in Turkey?
Give a very brief answer. 1.29. In the year 2006, what is the difference between the Electricity production(% of total) of Gabon and Electricity production(% of total) of Turkey?
Make the answer very short. 0.32. In the year 2007, what is the difference between the Electricity production(% of total) in High income and Electricity production(% of total) in Cambodia?
Your answer should be compact. 1.86. In the year 2007, what is the difference between the Electricity production(% of total) in High income and Electricity production(% of total) in Gabon?
Provide a short and direct response. 2.61. In the year 2007, what is the difference between the Electricity production(% of total) in High income and Electricity production(% of total) in Turkey?
Give a very brief answer. 2.76. In the year 2007, what is the difference between the Electricity production(% of total) of Cambodia and Electricity production(% of total) of Gabon?
Keep it short and to the point. 0.75. In the year 2007, what is the difference between the Electricity production(% of total) in Cambodia and Electricity production(% of total) in Turkey?
Your response must be concise. 0.89. In the year 2007, what is the difference between the Electricity production(% of total) in Gabon and Electricity production(% of total) in Turkey?
Your answer should be very brief. 0.14. What is the ratio of the Electricity production(% of total) in High income in 2000 to that in 2001?
Make the answer very short. 0.97. What is the ratio of the Electricity production(% of total) in Cambodia in 2000 to that in 2001?
Offer a very short reply. 1.14. What is the ratio of the Electricity production(% of total) of Gabon in 2000 to that in 2001?
Provide a short and direct response. 1.06. What is the ratio of the Electricity production(% of total) of Turkey in 2000 to that in 2001?
Offer a very short reply. 0.8. What is the ratio of the Electricity production(% of total) of High income in 2000 to that in 2002?
Make the answer very short. 0.87. What is the ratio of the Electricity production(% of total) of Cambodia in 2000 to that in 2002?
Your answer should be very brief. 1.62. What is the ratio of the Electricity production(% of total) in Gabon in 2000 to that in 2002?
Give a very brief answer. 1.12. What is the ratio of the Electricity production(% of total) of Turkey in 2000 to that in 2002?
Keep it short and to the point. 1.01. What is the ratio of the Electricity production(% of total) of High income in 2000 to that in 2003?
Keep it short and to the point. 0.8. What is the ratio of the Electricity production(% of total) in Cambodia in 2000 to that in 2003?
Provide a succinct answer. 0.21. What is the ratio of the Electricity production(% of total) in Gabon in 2000 to that in 2003?
Make the answer very short. 1.01. What is the ratio of the Electricity production(% of total) in Turkey in 2000 to that in 2003?
Give a very brief answer. 1.35. What is the ratio of the Electricity production(% of total) of High income in 2000 to that in 2004?
Your answer should be very brief. 0.72. What is the ratio of the Electricity production(% of total) in Cambodia in 2000 to that in 2004?
Your answer should be compact. 0.13. What is the ratio of the Electricity production(% of total) in Turkey in 2000 to that in 2004?
Your answer should be compact. 1.46. What is the ratio of the Electricity production(% of total) in High income in 2000 to that in 2005?
Provide a short and direct response. 0.64. What is the ratio of the Electricity production(% of total) in Cambodia in 2000 to that in 2005?
Offer a very short reply. 0.14. What is the ratio of the Electricity production(% of total) of Gabon in 2000 to that in 2005?
Provide a succinct answer. 1.04. What is the ratio of the Electricity production(% of total) of Turkey in 2000 to that in 2005?
Make the answer very short. 1.91. What is the ratio of the Electricity production(% of total) in High income in 2000 to that in 2006?
Provide a short and direct response. 0.58. What is the ratio of the Electricity production(% of total) in Cambodia in 2000 to that in 2006?
Make the answer very short. 0.15. What is the ratio of the Electricity production(% of total) of Gabon in 2000 to that in 2006?
Your answer should be compact. 1.11. What is the ratio of the Electricity production(% of total) of Turkey in 2000 to that in 2006?
Offer a very short reply. 1.4. What is the ratio of the Electricity production(% of total) of High income in 2000 to that in 2007?
Your answer should be compact. 0.52. What is the ratio of the Electricity production(% of total) in Cambodia in 2000 to that in 2007?
Your answer should be compact. 0.18. What is the ratio of the Electricity production(% of total) of Gabon in 2000 to that in 2007?
Your response must be concise. 1.16. What is the ratio of the Electricity production(% of total) in Turkey in 2000 to that in 2007?
Keep it short and to the point. 0.7. What is the ratio of the Electricity production(% of total) in High income in 2001 to that in 2002?
Your answer should be very brief. 0.89. What is the ratio of the Electricity production(% of total) in Cambodia in 2001 to that in 2002?
Offer a very short reply. 1.43. What is the ratio of the Electricity production(% of total) in Gabon in 2001 to that in 2002?
Your answer should be very brief. 1.06. What is the ratio of the Electricity production(% of total) of Turkey in 2001 to that in 2002?
Your answer should be very brief. 1.25. What is the ratio of the Electricity production(% of total) in High income in 2001 to that in 2003?
Ensure brevity in your answer.  0.83. What is the ratio of the Electricity production(% of total) in Cambodia in 2001 to that in 2003?
Offer a terse response. 0.19. What is the ratio of the Electricity production(% of total) in Gabon in 2001 to that in 2003?
Give a very brief answer. 0.95. What is the ratio of the Electricity production(% of total) of Turkey in 2001 to that in 2003?
Provide a short and direct response. 1.68. What is the ratio of the Electricity production(% of total) of High income in 2001 to that in 2004?
Your response must be concise. 0.74. What is the ratio of the Electricity production(% of total) in Cambodia in 2001 to that in 2004?
Make the answer very short. 0.11. What is the ratio of the Electricity production(% of total) of Gabon in 2001 to that in 2004?
Offer a very short reply. 0.97. What is the ratio of the Electricity production(% of total) of Turkey in 2001 to that in 2004?
Make the answer very short. 1.82. What is the ratio of the Electricity production(% of total) of High income in 2001 to that in 2005?
Offer a terse response. 0.66. What is the ratio of the Electricity production(% of total) in Cambodia in 2001 to that in 2005?
Ensure brevity in your answer.  0.13. What is the ratio of the Electricity production(% of total) of Gabon in 2001 to that in 2005?
Keep it short and to the point. 0.98. What is the ratio of the Electricity production(% of total) in Turkey in 2001 to that in 2005?
Provide a short and direct response. 2.37. What is the ratio of the Electricity production(% of total) in High income in 2001 to that in 2006?
Make the answer very short. 0.6. What is the ratio of the Electricity production(% of total) in Cambodia in 2001 to that in 2006?
Make the answer very short. 0.14. What is the ratio of the Electricity production(% of total) in Gabon in 2001 to that in 2006?
Ensure brevity in your answer.  1.04. What is the ratio of the Electricity production(% of total) of Turkey in 2001 to that in 2006?
Make the answer very short. 1.74. What is the ratio of the Electricity production(% of total) in High income in 2001 to that in 2007?
Ensure brevity in your answer.  0.53. What is the ratio of the Electricity production(% of total) in Cambodia in 2001 to that in 2007?
Provide a short and direct response. 0.16. What is the ratio of the Electricity production(% of total) of Gabon in 2001 to that in 2007?
Provide a short and direct response. 1.1. What is the ratio of the Electricity production(% of total) of Turkey in 2001 to that in 2007?
Ensure brevity in your answer.  0.87. What is the ratio of the Electricity production(% of total) of High income in 2002 to that in 2003?
Provide a short and direct response. 0.92. What is the ratio of the Electricity production(% of total) of Cambodia in 2002 to that in 2003?
Your response must be concise. 0.13. What is the ratio of the Electricity production(% of total) of Gabon in 2002 to that in 2003?
Offer a terse response. 0.9. What is the ratio of the Electricity production(% of total) of Turkey in 2002 to that in 2003?
Offer a very short reply. 1.34. What is the ratio of the Electricity production(% of total) of High income in 2002 to that in 2004?
Your answer should be compact. 0.83. What is the ratio of the Electricity production(% of total) of Cambodia in 2002 to that in 2004?
Your response must be concise. 0.08. What is the ratio of the Electricity production(% of total) in Gabon in 2002 to that in 2004?
Your answer should be very brief. 0.91. What is the ratio of the Electricity production(% of total) of Turkey in 2002 to that in 2004?
Keep it short and to the point. 1.45. What is the ratio of the Electricity production(% of total) in High income in 2002 to that in 2005?
Offer a terse response. 0.74. What is the ratio of the Electricity production(% of total) in Cambodia in 2002 to that in 2005?
Offer a terse response. 0.09. What is the ratio of the Electricity production(% of total) of Gabon in 2002 to that in 2005?
Keep it short and to the point. 0.93. What is the ratio of the Electricity production(% of total) of Turkey in 2002 to that in 2005?
Provide a succinct answer. 1.89. What is the ratio of the Electricity production(% of total) of High income in 2002 to that in 2006?
Provide a short and direct response. 0.67. What is the ratio of the Electricity production(% of total) in Cambodia in 2002 to that in 2006?
Make the answer very short. 0.1. What is the ratio of the Electricity production(% of total) in Gabon in 2002 to that in 2006?
Offer a very short reply. 0.98. What is the ratio of the Electricity production(% of total) in Turkey in 2002 to that in 2006?
Keep it short and to the point. 1.39. What is the ratio of the Electricity production(% of total) of High income in 2002 to that in 2007?
Provide a short and direct response. 0.6. What is the ratio of the Electricity production(% of total) in Cambodia in 2002 to that in 2007?
Keep it short and to the point. 0.11. What is the ratio of the Electricity production(% of total) in Gabon in 2002 to that in 2007?
Offer a terse response. 1.03. What is the ratio of the Electricity production(% of total) in Turkey in 2002 to that in 2007?
Provide a short and direct response. 0.69. What is the ratio of the Electricity production(% of total) in High income in 2003 to that in 2004?
Provide a succinct answer. 0.89. What is the ratio of the Electricity production(% of total) in Cambodia in 2003 to that in 2004?
Your answer should be compact. 0.61. What is the ratio of the Electricity production(% of total) of Gabon in 2003 to that in 2004?
Ensure brevity in your answer.  1.01. What is the ratio of the Electricity production(% of total) in Turkey in 2003 to that in 2004?
Give a very brief answer. 1.08. What is the ratio of the Electricity production(% of total) in High income in 2003 to that in 2005?
Provide a short and direct response. 0.8. What is the ratio of the Electricity production(% of total) in Cambodia in 2003 to that in 2005?
Provide a succinct answer. 0.67. What is the ratio of the Electricity production(% of total) of Gabon in 2003 to that in 2005?
Make the answer very short. 1.03. What is the ratio of the Electricity production(% of total) of Turkey in 2003 to that in 2005?
Your response must be concise. 1.41. What is the ratio of the Electricity production(% of total) of High income in 2003 to that in 2006?
Give a very brief answer. 0.72. What is the ratio of the Electricity production(% of total) of Cambodia in 2003 to that in 2006?
Offer a terse response. 0.73. What is the ratio of the Electricity production(% of total) of Gabon in 2003 to that in 2006?
Make the answer very short. 1.09. What is the ratio of the Electricity production(% of total) of Turkey in 2003 to that in 2006?
Offer a very short reply. 1.03. What is the ratio of the Electricity production(% of total) of High income in 2003 to that in 2007?
Make the answer very short. 0.65. What is the ratio of the Electricity production(% of total) of Cambodia in 2003 to that in 2007?
Your response must be concise. 0.87. What is the ratio of the Electricity production(% of total) of Gabon in 2003 to that in 2007?
Provide a short and direct response. 1.15. What is the ratio of the Electricity production(% of total) in Turkey in 2003 to that in 2007?
Offer a terse response. 0.51. What is the ratio of the Electricity production(% of total) of High income in 2004 to that in 2005?
Provide a succinct answer. 0.9. What is the ratio of the Electricity production(% of total) of Cambodia in 2004 to that in 2005?
Your answer should be compact. 1.11. What is the ratio of the Electricity production(% of total) of Gabon in 2004 to that in 2005?
Provide a short and direct response. 1.02. What is the ratio of the Electricity production(% of total) of Turkey in 2004 to that in 2005?
Offer a terse response. 1.3. What is the ratio of the Electricity production(% of total) of High income in 2004 to that in 2006?
Make the answer very short. 0.81. What is the ratio of the Electricity production(% of total) in Cambodia in 2004 to that in 2006?
Your answer should be compact. 1.19. What is the ratio of the Electricity production(% of total) in Gabon in 2004 to that in 2006?
Provide a short and direct response. 1.08. What is the ratio of the Electricity production(% of total) of Turkey in 2004 to that in 2006?
Ensure brevity in your answer.  0.96. What is the ratio of the Electricity production(% of total) of High income in 2004 to that in 2007?
Make the answer very short. 0.72. What is the ratio of the Electricity production(% of total) of Cambodia in 2004 to that in 2007?
Your answer should be very brief. 1.42. What is the ratio of the Electricity production(% of total) of Gabon in 2004 to that in 2007?
Ensure brevity in your answer.  1.13. What is the ratio of the Electricity production(% of total) of Turkey in 2004 to that in 2007?
Provide a short and direct response. 0.48. What is the ratio of the Electricity production(% of total) in High income in 2005 to that in 2006?
Your answer should be very brief. 0.9. What is the ratio of the Electricity production(% of total) of Cambodia in 2005 to that in 2006?
Keep it short and to the point. 1.08. What is the ratio of the Electricity production(% of total) of Gabon in 2005 to that in 2006?
Make the answer very short. 1.06. What is the ratio of the Electricity production(% of total) in Turkey in 2005 to that in 2006?
Make the answer very short. 0.73. What is the ratio of the Electricity production(% of total) in High income in 2005 to that in 2007?
Offer a terse response. 0.81. What is the ratio of the Electricity production(% of total) of Cambodia in 2005 to that in 2007?
Offer a very short reply. 1.29. What is the ratio of the Electricity production(% of total) in Gabon in 2005 to that in 2007?
Give a very brief answer. 1.11. What is the ratio of the Electricity production(% of total) in Turkey in 2005 to that in 2007?
Offer a terse response. 0.36. What is the ratio of the Electricity production(% of total) in High income in 2006 to that in 2007?
Give a very brief answer. 0.89. What is the ratio of the Electricity production(% of total) in Cambodia in 2006 to that in 2007?
Offer a terse response. 1.2. What is the ratio of the Electricity production(% of total) of Gabon in 2006 to that in 2007?
Provide a succinct answer. 1.05. What is the ratio of the Electricity production(% of total) of Turkey in 2006 to that in 2007?
Your answer should be very brief. 0.5. What is the difference between the highest and the second highest Electricity production(% of total) of High income?
Offer a very short reply. 0.33. What is the difference between the highest and the second highest Electricity production(% of total) in Cambodia?
Offer a terse response. 0.16. What is the difference between the highest and the second highest Electricity production(% of total) in Gabon?
Give a very brief answer. 0.01. What is the difference between the highest and the second highest Electricity production(% of total) of Turkey?
Provide a short and direct response. 0.04. What is the difference between the highest and the lowest Electricity production(% of total) of High income?
Offer a terse response. 1.49. What is the difference between the highest and the lowest Electricity production(% of total) in Cambodia?
Give a very brief answer. 1.58. What is the difference between the highest and the lowest Electricity production(% of total) in Gabon?
Offer a terse response. 0.07. What is the difference between the highest and the lowest Electricity production(% of total) in Turkey?
Keep it short and to the point. 0.2. 